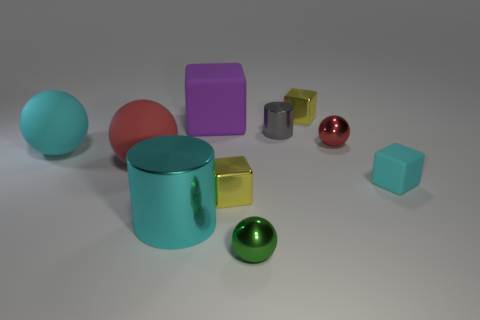Subtract all brown balls. Subtract all brown cubes. How many balls are left? 4 Subtract all spheres. How many objects are left? 6 Add 6 big cyan rubber objects. How many big cyan rubber objects are left? 7 Add 5 big cylinders. How many big cylinders exist? 6 Subtract 0 blue cubes. How many objects are left? 10 Subtract all small brown spheres. Subtract all matte blocks. How many objects are left? 8 